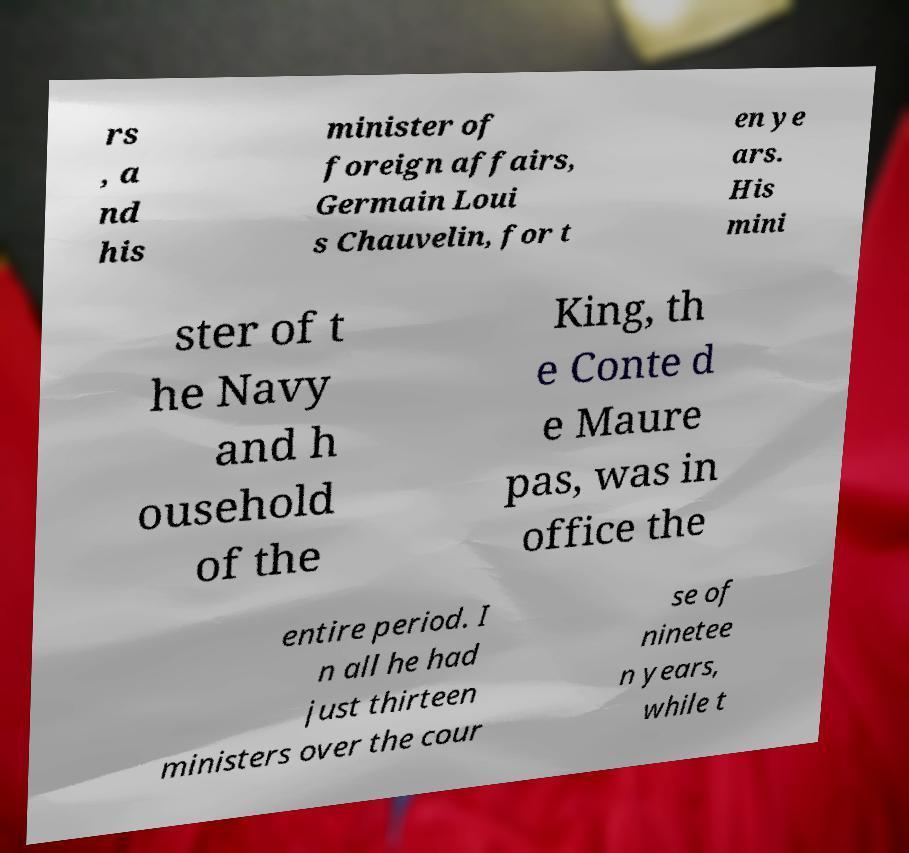Can you accurately transcribe the text from the provided image for me? rs , a nd his minister of foreign affairs, Germain Loui s Chauvelin, for t en ye ars. His mini ster of t he Navy and h ousehold of the King, th e Conte d e Maure pas, was in office the entire period. I n all he had just thirteen ministers over the cour se of ninetee n years, while t 